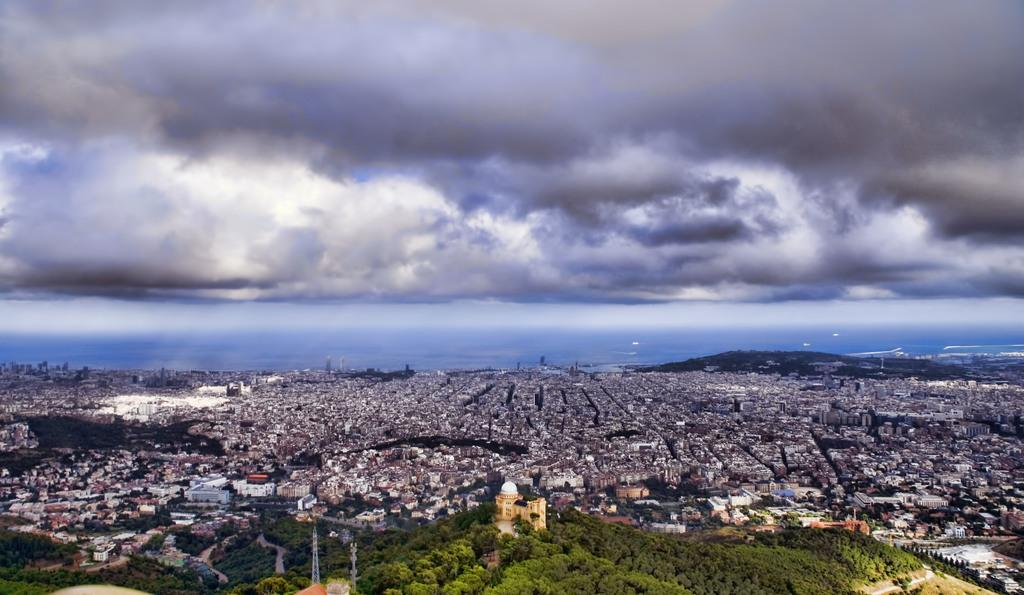What is the primary subject of the image? The primary subject of the image is many buildings. What type of vegetation can be seen in the image? There are trees in the image. What is the condition of the sky in the image? The sky is cloudy in the image. What type of class is being held in the image? There is no class present in the image; it features many buildings, trees, and a cloudy sky. Can you see a letter being written in the image? There is no letter being written in the image. What type of gardening tool is visible in the image? There is no gardening tool, such as a rake, present in the image. 